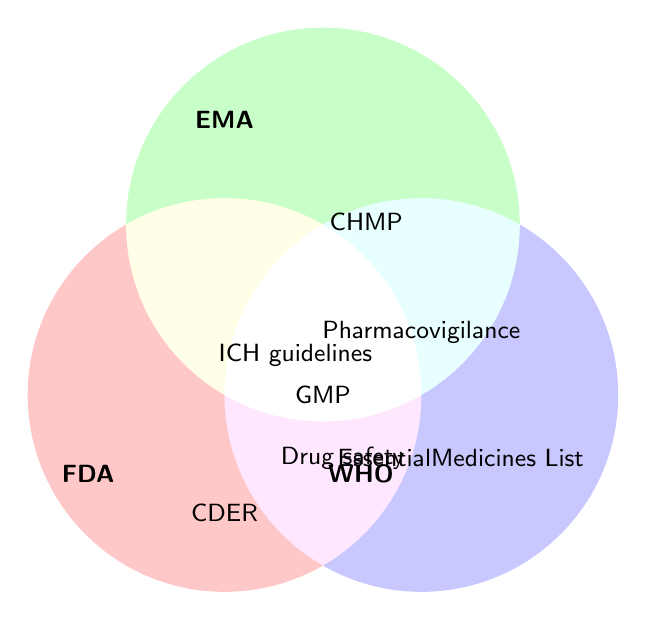What regulatory bodies are represented in the Venn Diagram? The figure represents the FDA, EMA, and WHO based on the labels provided in the figure.
Answer: FDA, EMA, WHO Which regulatory body is associated with "CHMP"? CHMP is located within the EMA circle, indicating it is specific to the EMA.
Answer: EMA What concept is at the intersection of all three regulatory bodies? The figure shows "GMP" located where all three circles intersect. This means GMP standards are shared by the FDA, EMA, and WHO.
Answer: GMP Which regulatory bodies share the responsibility of "Pharmacovigilance"? The figure shows "Pharmacovigilance" at the intersection of EMA and WHO, meaning both share this responsibility.
Answer: EMA and WHO Where is "ICH guidelines" positioned, and which bodies share it? "ICH guidelines" is located in the intersection of FDA and EMA, meaning these guidelines are shared by both the FDA and EMA.
Answer: FDA and EMA What is unique to the WHO, according to the diagram? The "Essential Medicines List" is shown within the WHO circle, indicating it is unique to the WHO.
Answer: Essential Medicines List Which bodies are involved in "Drug safety monitoring"? The term "Drug safety" is shown to be shared between FDA and WHO.
Answer: FDA and WHO Where is the "Orange Book" positioned, and which body does it belong to? The "Orange Book" is located within the FDA circle, indicating it is specific to the FDA.
Answer: FDA 